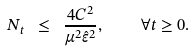<formula> <loc_0><loc_0><loc_500><loc_500>N _ { t } \ \leq \ \frac { 4 C ^ { 2 } } { \mu ^ { 2 } \hat { \varepsilon } ^ { 2 } } , \quad \forall t \geq 0 .</formula> 